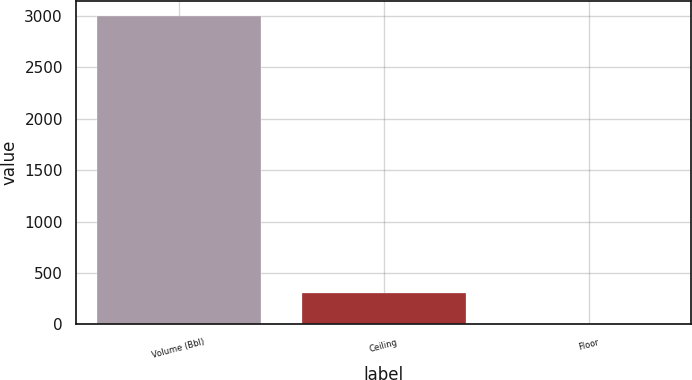<chart> <loc_0><loc_0><loc_500><loc_500><bar_chart><fcel>Volume (Bbl)<fcel>Ceiling<fcel>Floor<nl><fcel>3000<fcel>307.81<fcel>8.68<nl></chart> 